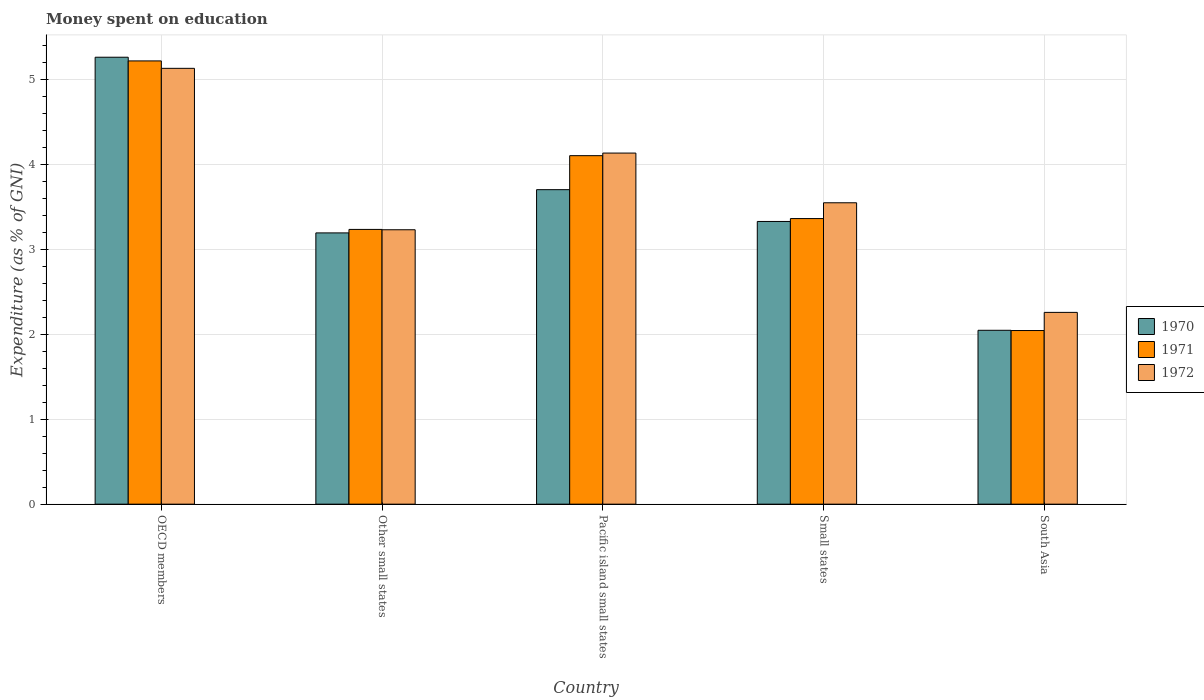How many groups of bars are there?
Offer a terse response. 5. How many bars are there on the 1st tick from the left?
Provide a short and direct response. 3. How many bars are there on the 5th tick from the right?
Ensure brevity in your answer.  3. What is the label of the 4th group of bars from the left?
Make the answer very short. Small states. In how many cases, is the number of bars for a given country not equal to the number of legend labels?
Provide a short and direct response. 0. What is the amount of money spent on education in 1970 in South Asia?
Provide a succinct answer. 2.05. Across all countries, what is the maximum amount of money spent on education in 1972?
Ensure brevity in your answer.  5.13. Across all countries, what is the minimum amount of money spent on education in 1970?
Your answer should be very brief. 2.05. In which country was the amount of money spent on education in 1970 maximum?
Your answer should be compact. OECD members. What is the total amount of money spent on education in 1970 in the graph?
Offer a terse response. 17.52. What is the difference between the amount of money spent on education in 1972 in OECD members and that in South Asia?
Offer a very short reply. 2.87. What is the difference between the amount of money spent on education in 1972 in Small states and the amount of money spent on education in 1970 in South Asia?
Your answer should be very brief. 1.5. What is the average amount of money spent on education in 1972 per country?
Your answer should be compact. 3.66. What is the difference between the amount of money spent on education of/in 1971 and amount of money spent on education of/in 1970 in OECD members?
Ensure brevity in your answer.  -0.04. What is the ratio of the amount of money spent on education in 1972 in Pacific island small states to that in Small states?
Your answer should be very brief. 1.16. Is the difference between the amount of money spent on education in 1971 in OECD members and Small states greater than the difference between the amount of money spent on education in 1970 in OECD members and Small states?
Offer a terse response. No. What is the difference between the highest and the second highest amount of money spent on education in 1972?
Offer a terse response. -0.58. What is the difference between the highest and the lowest amount of money spent on education in 1972?
Offer a terse response. 2.87. Is the sum of the amount of money spent on education in 1972 in Other small states and Pacific island small states greater than the maximum amount of money spent on education in 1970 across all countries?
Offer a terse response. Yes. Is it the case that in every country, the sum of the amount of money spent on education in 1970 and amount of money spent on education in 1971 is greater than the amount of money spent on education in 1972?
Your answer should be very brief. Yes. What is the difference between two consecutive major ticks on the Y-axis?
Give a very brief answer. 1. Does the graph contain grids?
Provide a short and direct response. Yes. How are the legend labels stacked?
Your response must be concise. Vertical. What is the title of the graph?
Your answer should be very brief. Money spent on education. What is the label or title of the Y-axis?
Your response must be concise. Expenditure (as % of GNI). What is the Expenditure (as % of GNI) of 1970 in OECD members?
Your response must be concise. 5.26. What is the Expenditure (as % of GNI) in 1971 in OECD members?
Offer a terse response. 5.21. What is the Expenditure (as % of GNI) in 1972 in OECD members?
Ensure brevity in your answer.  5.13. What is the Expenditure (as % of GNI) in 1970 in Other small states?
Offer a very short reply. 3.19. What is the Expenditure (as % of GNI) of 1971 in Other small states?
Provide a short and direct response. 3.23. What is the Expenditure (as % of GNI) in 1972 in Other small states?
Provide a short and direct response. 3.23. What is the Expenditure (as % of GNI) in 1970 in Pacific island small states?
Provide a short and direct response. 3.7. What is the Expenditure (as % of GNI) in 1971 in Pacific island small states?
Provide a succinct answer. 4.1. What is the Expenditure (as % of GNI) of 1972 in Pacific island small states?
Ensure brevity in your answer.  4.13. What is the Expenditure (as % of GNI) of 1970 in Small states?
Offer a terse response. 3.33. What is the Expenditure (as % of GNI) in 1971 in Small states?
Your answer should be very brief. 3.36. What is the Expenditure (as % of GNI) of 1972 in Small states?
Offer a terse response. 3.55. What is the Expenditure (as % of GNI) in 1970 in South Asia?
Provide a short and direct response. 2.05. What is the Expenditure (as % of GNI) in 1971 in South Asia?
Your response must be concise. 2.04. What is the Expenditure (as % of GNI) in 1972 in South Asia?
Ensure brevity in your answer.  2.26. Across all countries, what is the maximum Expenditure (as % of GNI) in 1970?
Offer a terse response. 5.26. Across all countries, what is the maximum Expenditure (as % of GNI) of 1971?
Provide a short and direct response. 5.21. Across all countries, what is the maximum Expenditure (as % of GNI) in 1972?
Offer a terse response. 5.13. Across all countries, what is the minimum Expenditure (as % of GNI) in 1970?
Provide a short and direct response. 2.05. Across all countries, what is the minimum Expenditure (as % of GNI) of 1971?
Ensure brevity in your answer.  2.04. Across all countries, what is the minimum Expenditure (as % of GNI) of 1972?
Ensure brevity in your answer.  2.26. What is the total Expenditure (as % of GNI) in 1970 in the graph?
Make the answer very short. 17.52. What is the total Expenditure (as % of GNI) in 1971 in the graph?
Offer a very short reply. 17.95. What is the total Expenditure (as % of GNI) in 1972 in the graph?
Your response must be concise. 18.29. What is the difference between the Expenditure (as % of GNI) in 1970 in OECD members and that in Other small states?
Keep it short and to the point. 2.07. What is the difference between the Expenditure (as % of GNI) of 1971 in OECD members and that in Other small states?
Provide a short and direct response. 1.98. What is the difference between the Expenditure (as % of GNI) in 1972 in OECD members and that in Other small states?
Your response must be concise. 1.9. What is the difference between the Expenditure (as % of GNI) of 1970 in OECD members and that in Pacific island small states?
Make the answer very short. 1.56. What is the difference between the Expenditure (as % of GNI) in 1971 in OECD members and that in Pacific island small states?
Provide a succinct answer. 1.11. What is the difference between the Expenditure (as % of GNI) of 1972 in OECD members and that in Pacific island small states?
Give a very brief answer. 1. What is the difference between the Expenditure (as % of GNI) of 1970 in OECD members and that in Small states?
Keep it short and to the point. 1.93. What is the difference between the Expenditure (as % of GNI) of 1971 in OECD members and that in Small states?
Make the answer very short. 1.85. What is the difference between the Expenditure (as % of GNI) in 1972 in OECD members and that in Small states?
Offer a terse response. 1.58. What is the difference between the Expenditure (as % of GNI) in 1970 in OECD members and that in South Asia?
Offer a terse response. 3.21. What is the difference between the Expenditure (as % of GNI) of 1971 in OECD members and that in South Asia?
Your answer should be very brief. 3.17. What is the difference between the Expenditure (as % of GNI) of 1972 in OECD members and that in South Asia?
Give a very brief answer. 2.87. What is the difference between the Expenditure (as % of GNI) in 1970 in Other small states and that in Pacific island small states?
Your answer should be very brief. -0.51. What is the difference between the Expenditure (as % of GNI) of 1971 in Other small states and that in Pacific island small states?
Keep it short and to the point. -0.87. What is the difference between the Expenditure (as % of GNI) in 1972 in Other small states and that in Pacific island small states?
Your response must be concise. -0.9. What is the difference between the Expenditure (as % of GNI) of 1970 in Other small states and that in Small states?
Keep it short and to the point. -0.13. What is the difference between the Expenditure (as % of GNI) in 1971 in Other small states and that in Small states?
Your answer should be compact. -0.13. What is the difference between the Expenditure (as % of GNI) in 1972 in Other small states and that in Small states?
Your answer should be very brief. -0.32. What is the difference between the Expenditure (as % of GNI) of 1970 in Other small states and that in South Asia?
Provide a short and direct response. 1.15. What is the difference between the Expenditure (as % of GNI) in 1971 in Other small states and that in South Asia?
Give a very brief answer. 1.19. What is the difference between the Expenditure (as % of GNI) of 1972 in Other small states and that in South Asia?
Make the answer very short. 0.97. What is the difference between the Expenditure (as % of GNI) of 1970 in Pacific island small states and that in Small states?
Make the answer very short. 0.37. What is the difference between the Expenditure (as % of GNI) in 1971 in Pacific island small states and that in Small states?
Provide a short and direct response. 0.74. What is the difference between the Expenditure (as % of GNI) in 1972 in Pacific island small states and that in Small states?
Your answer should be very brief. 0.58. What is the difference between the Expenditure (as % of GNI) of 1970 in Pacific island small states and that in South Asia?
Provide a short and direct response. 1.65. What is the difference between the Expenditure (as % of GNI) of 1971 in Pacific island small states and that in South Asia?
Your answer should be compact. 2.06. What is the difference between the Expenditure (as % of GNI) of 1972 in Pacific island small states and that in South Asia?
Give a very brief answer. 1.87. What is the difference between the Expenditure (as % of GNI) of 1970 in Small states and that in South Asia?
Make the answer very short. 1.28. What is the difference between the Expenditure (as % of GNI) of 1971 in Small states and that in South Asia?
Your response must be concise. 1.32. What is the difference between the Expenditure (as % of GNI) of 1972 in Small states and that in South Asia?
Give a very brief answer. 1.29. What is the difference between the Expenditure (as % of GNI) of 1970 in OECD members and the Expenditure (as % of GNI) of 1971 in Other small states?
Make the answer very short. 2.03. What is the difference between the Expenditure (as % of GNI) of 1970 in OECD members and the Expenditure (as % of GNI) of 1972 in Other small states?
Keep it short and to the point. 2.03. What is the difference between the Expenditure (as % of GNI) of 1971 in OECD members and the Expenditure (as % of GNI) of 1972 in Other small states?
Offer a terse response. 1.99. What is the difference between the Expenditure (as % of GNI) in 1970 in OECD members and the Expenditure (as % of GNI) in 1971 in Pacific island small states?
Offer a very short reply. 1.16. What is the difference between the Expenditure (as % of GNI) of 1970 in OECD members and the Expenditure (as % of GNI) of 1972 in Pacific island small states?
Keep it short and to the point. 1.13. What is the difference between the Expenditure (as % of GNI) of 1971 in OECD members and the Expenditure (as % of GNI) of 1972 in Pacific island small states?
Offer a very short reply. 1.08. What is the difference between the Expenditure (as % of GNI) of 1970 in OECD members and the Expenditure (as % of GNI) of 1971 in Small states?
Your answer should be compact. 1.9. What is the difference between the Expenditure (as % of GNI) of 1970 in OECD members and the Expenditure (as % of GNI) of 1972 in Small states?
Offer a very short reply. 1.71. What is the difference between the Expenditure (as % of GNI) in 1971 in OECD members and the Expenditure (as % of GNI) in 1972 in Small states?
Your answer should be compact. 1.67. What is the difference between the Expenditure (as % of GNI) of 1970 in OECD members and the Expenditure (as % of GNI) of 1971 in South Asia?
Make the answer very short. 3.22. What is the difference between the Expenditure (as % of GNI) of 1970 in OECD members and the Expenditure (as % of GNI) of 1972 in South Asia?
Provide a succinct answer. 3. What is the difference between the Expenditure (as % of GNI) of 1971 in OECD members and the Expenditure (as % of GNI) of 1972 in South Asia?
Make the answer very short. 2.96. What is the difference between the Expenditure (as % of GNI) of 1970 in Other small states and the Expenditure (as % of GNI) of 1971 in Pacific island small states?
Ensure brevity in your answer.  -0.91. What is the difference between the Expenditure (as % of GNI) in 1970 in Other small states and the Expenditure (as % of GNI) in 1972 in Pacific island small states?
Provide a short and direct response. -0.94. What is the difference between the Expenditure (as % of GNI) in 1971 in Other small states and the Expenditure (as % of GNI) in 1972 in Pacific island small states?
Your response must be concise. -0.9. What is the difference between the Expenditure (as % of GNI) of 1970 in Other small states and the Expenditure (as % of GNI) of 1971 in Small states?
Your response must be concise. -0.17. What is the difference between the Expenditure (as % of GNI) in 1970 in Other small states and the Expenditure (as % of GNI) in 1972 in Small states?
Keep it short and to the point. -0.35. What is the difference between the Expenditure (as % of GNI) of 1971 in Other small states and the Expenditure (as % of GNI) of 1972 in Small states?
Make the answer very short. -0.31. What is the difference between the Expenditure (as % of GNI) of 1970 in Other small states and the Expenditure (as % of GNI) of 1971 in South Asia?
Make the answer very short. 1.15. What is the difference between the Expenditure (as % of GNI) of 1970 in Other small states and the Expenditure (as % of GNI) of 1972 in South Asia?
Offer a terse response. 0.94. What is the difference between the Expenditure (as % of GNI) of 1971 in Other small states and the Expenditure (as % of GNI) of 1972 in South Asia?
Offer a very short reply. 0.98. What is the difference between the Expenditure (as % of GNI) in 1970 in Pacific island small states and the Expenditure (as % of GNI) in 1971 in Small states?
Provide a succinct answer. 0.34. What is the difference between the Expenditure (as % of GNI) of 1970 in Pacific island small states and the Expenditure (as % of GNI) of 1972 in Small states?
Make the answer very short. 0.15. What is the difference between the Expenditure (as % of GNI) in 1971 in Pacific island small states and the Expenditure (as % of GNI) in 1972 in Small states?
Offer a very short reply. 0.55. What is the difference between the Expenditure (as % of GNI) in 1970 in Pacific island small states and the Expenditure (as % of GNI) in 1971 in South Asia?
Your response must be concise. 1.66. What is the difference between the Expenditure (as % of GNI) in 1970 in Pacific island small states and the Expenditure (as % of GNI) in 1972 in South Asia?
Ensure brevity in your answer.  1.44. What is the difference between the Expenditure (as % of GNI) of 1971 in Pacific island small states and the Expenditure (as % of GNI) of 1972 in South Asia?
Provide a short and direct response. 1.84. What is the difference between the Expenditure (as % of GNI) in 1970 in Small states and the Expenditure (as % of GNI) in 1971 in South Asia?
Provide a short and direct response. 1.28. What is the difference between the Expenditure (as % of GNI) of 1970 in Small states and the Expenditure (as % of GNI) of 1972 in South Asia?
Give a very brief answer. 1.07. What is the difference between the Expenditure (as % of GNI) of 1971 in Small states and the Expenditure (as % of GNI) of 1972 in South Asia?
Your answer should be very brief. 1.1. What is the average Expenditure (as % of GNI) in 1970 per country?
Your answer should be very brief. 3.5. What is the average Expenditure (as % of GNI) in 1971 per country?
Provide a succinct answer. 3.59. What is the average Expenditure (as % of GNI) in 1972 per country?
Make the answer very short. 3.66. What is the difference between the Expenditure (as % of GNI) of 1970 and Expenditure (as % of GNI) of 1971 in OECD members?
Offer a terse response. 0.04. What is the difference between the Expenditure (as % of GNI) in 1970 and Expenditure (as % of GNI) in 1972 in OECD members?
Offer a very short reply. 0.13. What is the difference between the Expenditure (as % of GNI) of 1971 and Expenditure (as % of GNI) of 1972 in OECD members?
Your answer should be compact. 0.09. What is the difference between the Expenditure (as % of GNI) in 1970 and Expenditure (as % of GNI) in 1971 in Other small states?
Provide a succinct answer. -0.04. What is the difference between the Expenditure (as % of GNI) in 1970 and Expenditure (as % of GNI) in 1972 in Other small states?
Offer a very short reply. -0.04. What is the difference between the Expenditure (as % of GNI) in 1971 and Expenditure (as % of GNI) in 1972 in Other small states?
Provide a succinct answer. 0. What is the difference between the Expenditure (as % of GNI) in 1970 and Expenditure (as % of GNI) in 1971 in Pacific island small states?
Your answer should be very brief. -0.4. What is the difference between the Expenditure (as % of GNI) of 1970 and Expenditure (as % of GNI) of 1972 in Pacific island small states?
Your response must be concise. -0.43. What is the difference between the Expenditure (as % of GNI) of 1971 and Expenditure (as % of GNI) of 1972 in Pacific island small states?
Your answer should be very brief. -0.03. What is the difference between the Expenditure (as % of GNI) of 1970 and Expenditure (as % of GNI) of 1971 in Small states?
Offer a terse response. -0.03. What is the difference between the Expenditure (as % of GNI) of 1970 and Expenditure (as % of GNI) of 1972 in Small states?
Give a very brief answer. -0.22. What is the difference between the Expenditure (as % of GNI) of 1971 and Expenditure (as % of GNI) of 1972 in Small states?
Your response must be concise. -0.19. What is the difference between the Expenditure (as % of GNI) of 1970 and Expenditure (as % of GNI) of 1971 in South Asia?
Your answer should be compact. 0. What is the difference between the Expenditure (as % of GNI) in 1970 and Expenditure (as % of GNI) in 1972 in South Asia?
Give a very brief answer. -0.21. What is the difference between the Expenditure (as % of GNI) in 1971 and Expenditure (as % of GNI) in 1972 in South Asia?
Provide a succinct answer. -0.21. What is the ratio of the Expenditure (as % of GNI) of 1970 in OECD members to that in Other small states?
Ensure brevity in your answer.  1.65. What is the ratio of the Expenditure (as % of GNI) in 1971 in OECD members to that in Other small states?
Offer a very short reply. 1.61. What is the ratio of the Expenditure (as % of GNI) in 1972 in OECD members to that in Other small states?
Your response must be concise. 1.59. What is the ratio of the Expenditure (as % of GNI) in 1970 in OECD members to that in Pacific island small states?
Give a very brief answer. 1.42. What is the ratio of the Expenditure (as % of GNI) of 1971 in OECD members to that in Pacific island small states?
Your response must be concise. 1.27. What is the ratio of the Expenditure (as % of GNI) of 1972 in OECD members to that in Pacific island small states?
Provide a short and direct response. 1.24. What is the ratio of the Expenditure (as % of GNI) in 1970 in OECD members to that in Small states?
Offer a terse response. 1.58. What is the ratio of the Expenditure (as % of GNI) in 1971 in OECD members to that in Small states?
Ensure brevity in your answer.  1.55. What is the ratio of the Expenditure (as % of GNI) in 1972 in OECD members to that in Small states?
Your response must be concise. 1.45. What is the ratio of the Expenditure (as % of GNI) of 1970 in OECD members to that in South Asia?
Your answer should be very brief. 2.57. What is the ratio of the Expenditure (as % of GNI) of 1971 in OECD members to that in South Asia?
Provide a succinct answer. 2.55. What is the ratio of the Expenditure (as % of GNI) of 1972 in OECD members to that in South Asia?
Make the answer very short. 2.27. What is the ratio of the Expenditure (as % of GNI) in 1970 in Other small states to that in Pacific island small states?
Ensure brevity in your answer.  0.86. What is the ratio of the Expenditure (as % of GNI) of 1971 in Other small states to that in Pacific island small states?
Ensure brevity in your answer.  0.79. What is the ratio of the Expenditure (as % of GNI) in 1972 in Other small states to that in Pacific island small states?
Your response must be concise. 0.78. What is the ratio of the Expenditure (as % of GNI) of 1970 in Other small states to that in Small states?
Provide a short and direct response. 0.96. What is the ratio of the Expenditure (as % of GNI) of 1971 in Other small states to that in Small states?
Make the answer very short. 0.96. What is the ratio of the Expenditure (as % of GNI) of 1972 in Other small states to that in Small states?
Provide a short and direct response. 0.91. What is the ratio of the Expenditure (as % of GNI) in 1970 in Other small states to that in South Asia?
Ensure brevity in your answer.  1.56. What is the ratio of the Expenditure (as % of GNI) in 1971 in Other small states to that in South Asia?
Offer a terse response. 1.58. What is the ratio of the Expenditure (as % of GNI) in 1972 in Other small states to that in South Asia?
Your response must be concise. 1.43. What is the ratio of the Expenditure (as % of GNI) in 1970 in Pacific island small states to that in Small states?
Your response must be concise. 1.11. What is the ratio of the Expenditure (as % of GNI) of 1971 in Pacific island small states to that in Small states?
Your response must be concise. 1.22. What is the ratio of the Expenditure (as % of GNI) in 1972 in Pacific island small states to that in Small states?
Make the answer very short. 1.16. What is the ratio of the Expenditure (as % of GNI) in 1970 in Pacific island small states to that in South Asia?
Offer a very short reply. 1.81. What is the ratio of the Expenditure (as % of GNI) of 1971 in Pacific island small states to that in South Asia?
Ensure brevity in your answer.  2.01. What is the ratio of the Expenditure (as % of GNI) in 1972 in Pacific island small states to that in South Asia?
Keep it short and to the point. 1.83. What is the ratio of the Expenditure (as % of GNI) in 1970 in Small states to that in South Asia?
Ensure brevity in your answer.  1.63. What is the ratio of the Expenditure (as % of GNI) of 1971 in Small states to that in South Asia?
Your answer should be compact. 1.65. What is the ratio of the Expenditure (as % of GNI) in 1972 in Small states to that in South Asia?
Your response must be concise. 1.57. What is the difference between the highest and the second highest Expenditure (as % of GNI) of 1970?
Provide a short and direct response. 1.56. What is the difference between the highest and the second highest Expenditure (as % of GNI) of 1971?
Provide a short and direct response. 1.11. What is the difference between the highest and the second highest Expenditure (as % of GNI) of 1972?
Keep it short and to the point. 1. What is the difference between the highest and the lowest Expenditure (as % of GNI) of 1970?
Your response must be concise. 3.21. What is the difference between the highest and the lowest Expenditure (as % of GNI) in 1971?
Ensure brevity in your answer.  3.17. What is the difference between the highest and the lowest Expenditure (as % of GNI) of 1972?
Make the answer very short. 2.87. 